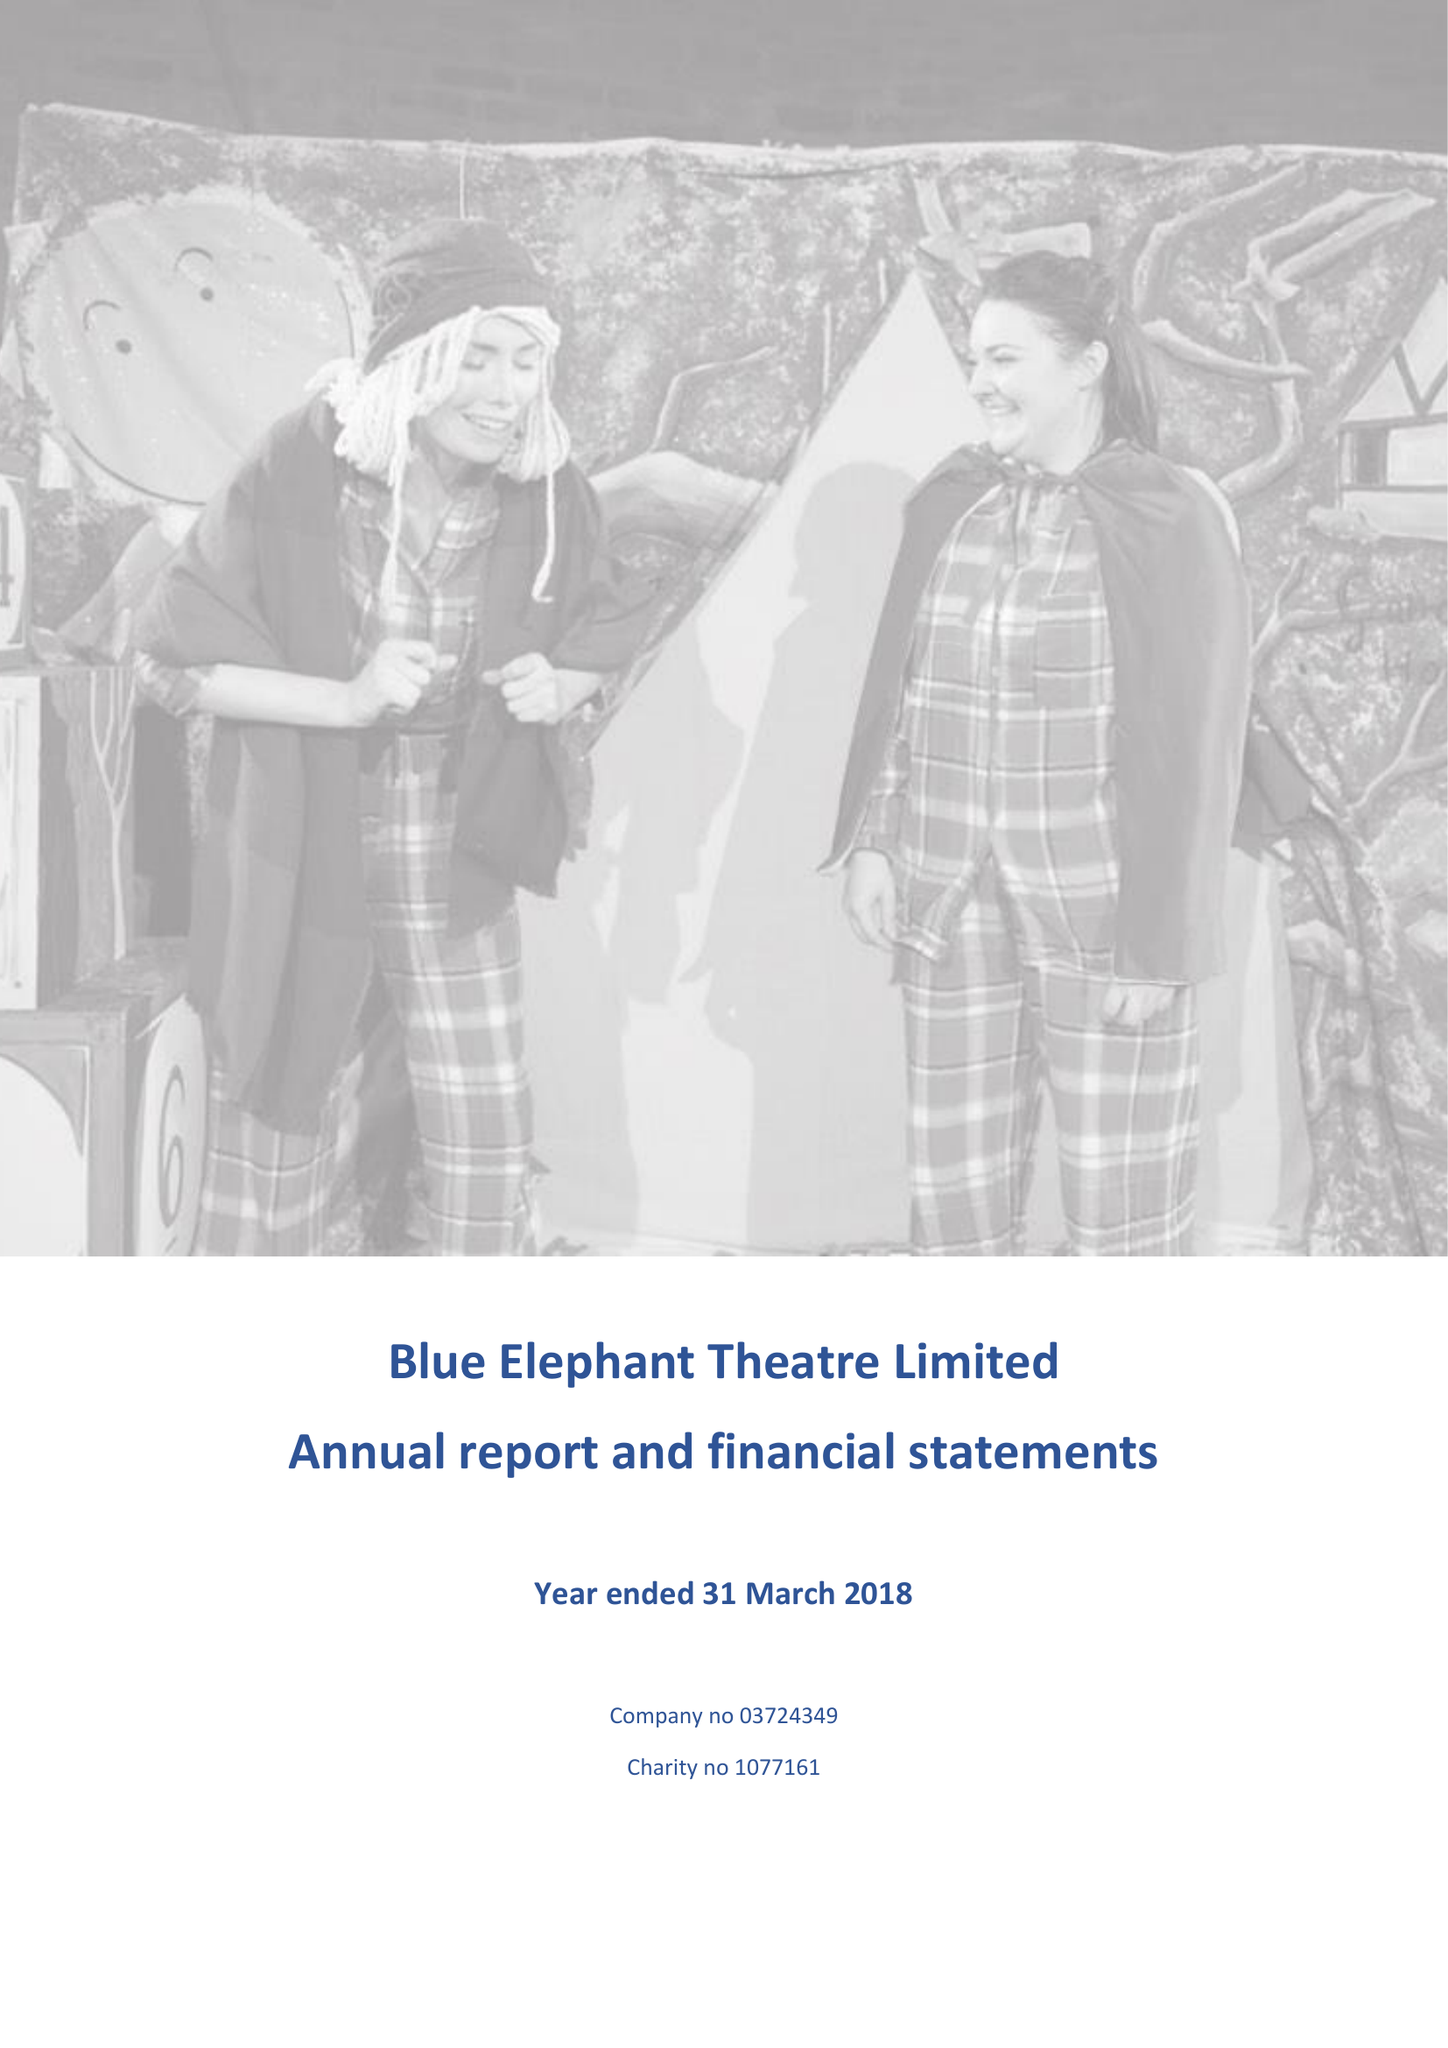What is the value for the spending_annually_in_british_pounds?
Answer the question using a single word or phrase. 161930.00 